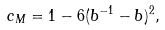<formula> <loc_0><loc_0><loc_500><loc_500>c _ { M } = 1 - 6 ( b ^ { - 1 } - b ) ^ { 2 } ,</formula> 